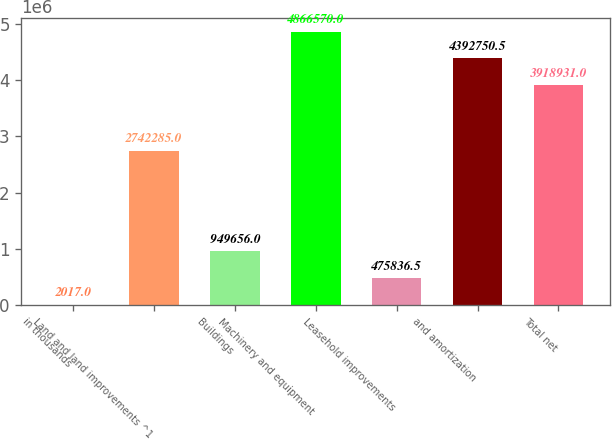Convert chart. <chart><loc_0><loc_0><loc_500><loc_500><bar_chart><fcel>in thousands<fcel>Land and land improvements ^1<fcel>Buildings<fcel>Machinery and equipment<fcel>Leasehold improvements<fcel>and amortization<fcel>Total net<nl><fcel>2017<fcel>2.74228e+06<fcel>949656<fcel>4.86657e+06<fcel>475836<fcel>4.39275e+06<fcel>3.91893e+06<nl></chart> 